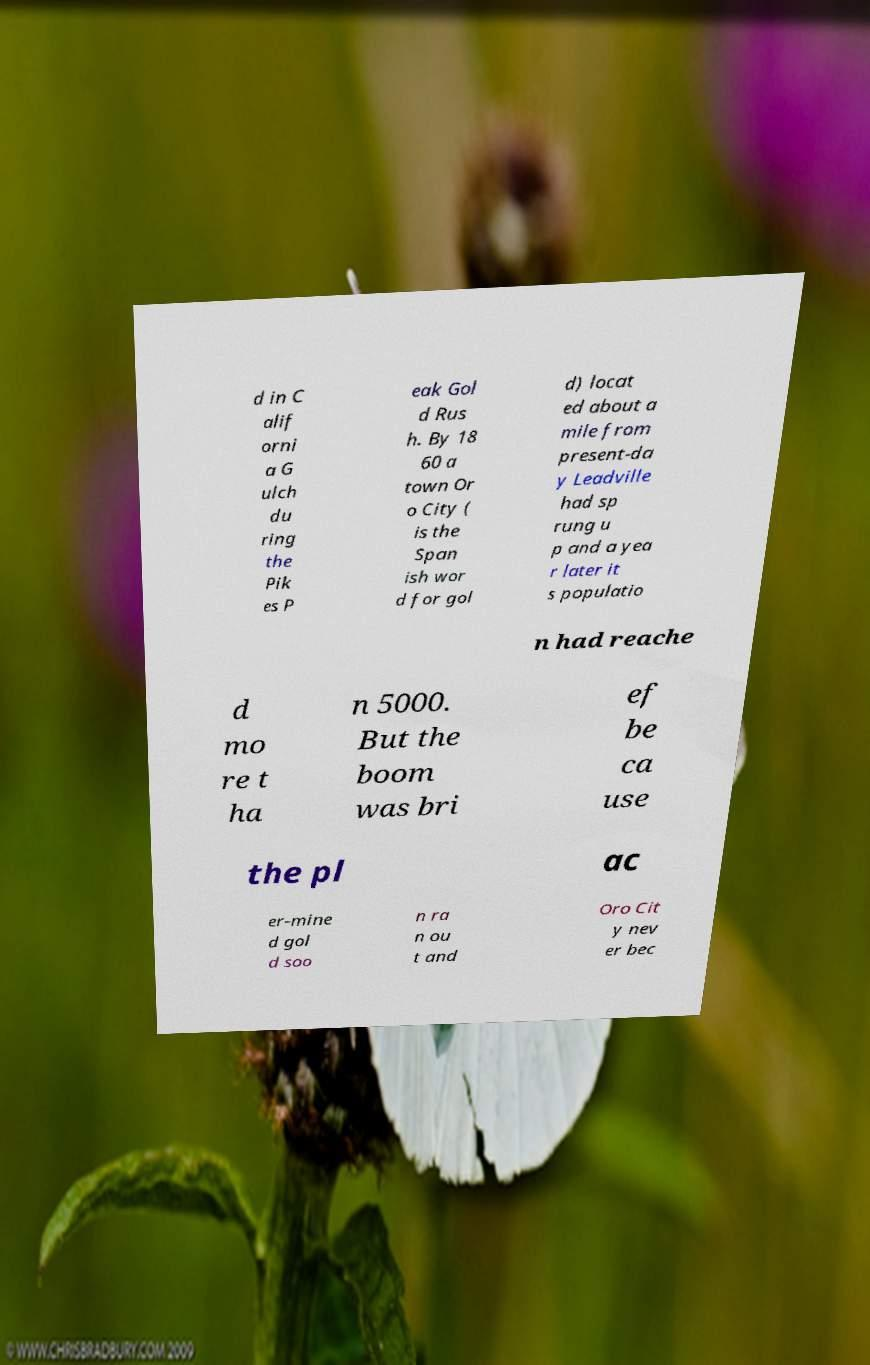What messages or text are displayed in this image? I need them in a readable, typed format. d in C alif orni a G ulch du ring the Pik es P eak Gol d Rus h. By 18 60 a town Or o City ( is the Span ish wor d for gol d) locat ed about a mile from present-da y Leadville had sp rung u p and a yea r later it s populatio n had reache d mo re t ha n 5000. But the boom was bri ef be ca use the pl ac er-mine d gol d soo n ra n ou t and Oro Cit y nev er bec 